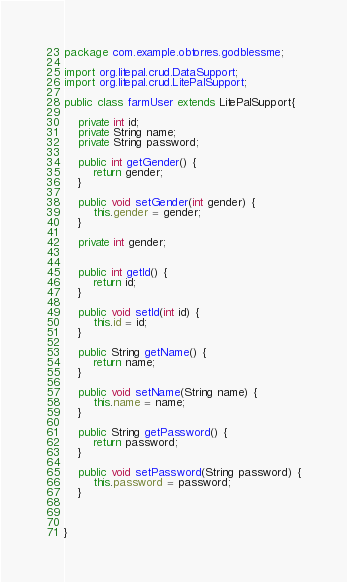Convert code to text. <code><loc_0><loc_0><loc_500><loc_500><_Java_>package com.example.obtorres.godblessme;

import org.litepal.crud.DataSupport;
import org.litepal.crud.LitePalSupport;

public class farmUser extends LitePalSupport{

    private int id;
    private String name;
    private String password;

    public int getGender() {
        return gender;
    }

    public void setGender(int gender) {
        this.gender = gender;
    }

    private int gender;


    public int getId() {
        return id;
    }

    public void setId(int id) {
        this.id = id;
    }

    public String getName() {
        return name;
    }

    public void setName(String name) {
        this.name = name;
    }

    public String getPassword() {
        return password;
    }

    public void setPassword(String password) {
        this.password = password;
    }



}
</code> 